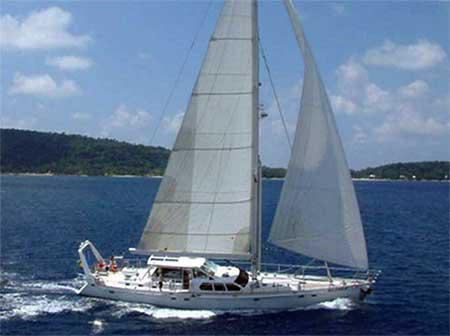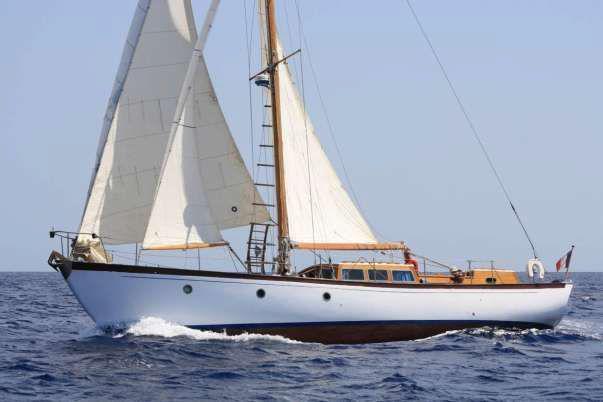The first image is the image on the left, the second image is the image on the right. Given the left and right images, does the statement "The two boats are heading towards each other." hold true? Answer yes or no. Yes. The first image is the image on the left, the second image is the image on the right. Analyze the images presented: Is the assertion "There are two white sailboats on the water." valid? Answer yes or no. Yes. 